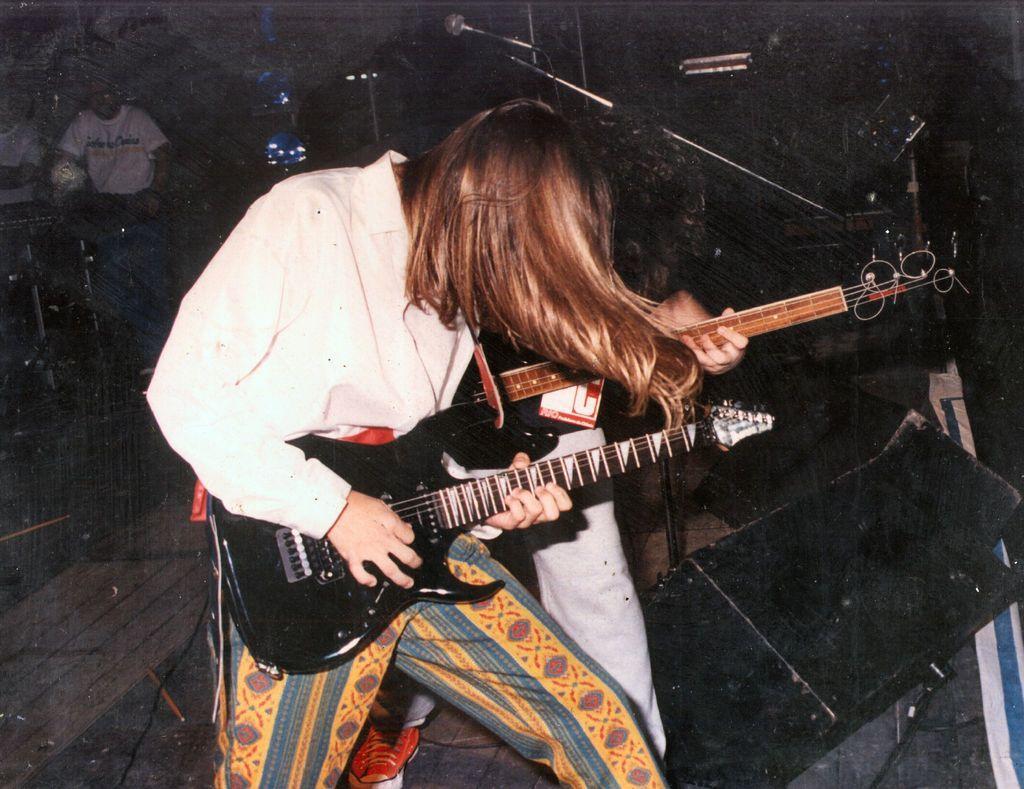How would you summarize this image in a sentence or two? In the center we can see man holding guitar. Back of him we can see one more man he is also holding guitar. Coming to the background we can see two more persons and one microphone. 